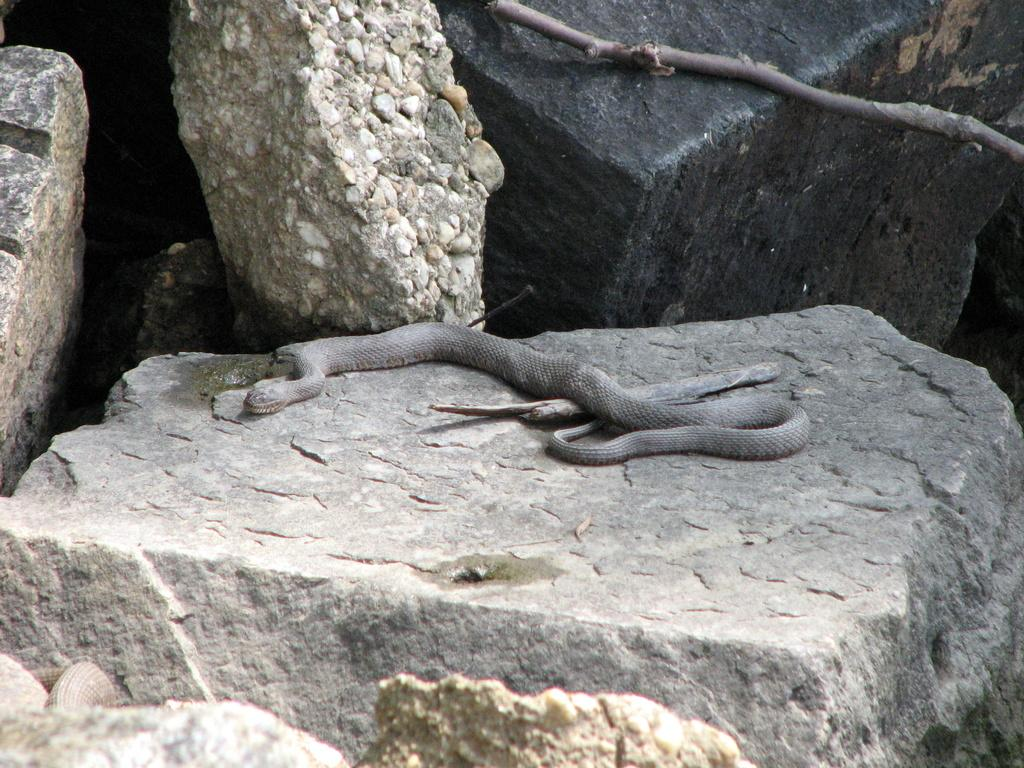What type of natural formation can be seen in the image? There are rocks in the image. What is located at the center of the rocks? There is a snake at the center of the rocks. What object is beside the snake? There is a wooden stick beside the snake. What type of earthquake can be seen in the image? There is no earthquake present in the image; it features rocks, a snake, and a wooden stick. Who is the expert on the rocks in the image? There is no expert mentioned or depicted in the image; it simply shows rocks, a snake, and a wooden stick. 